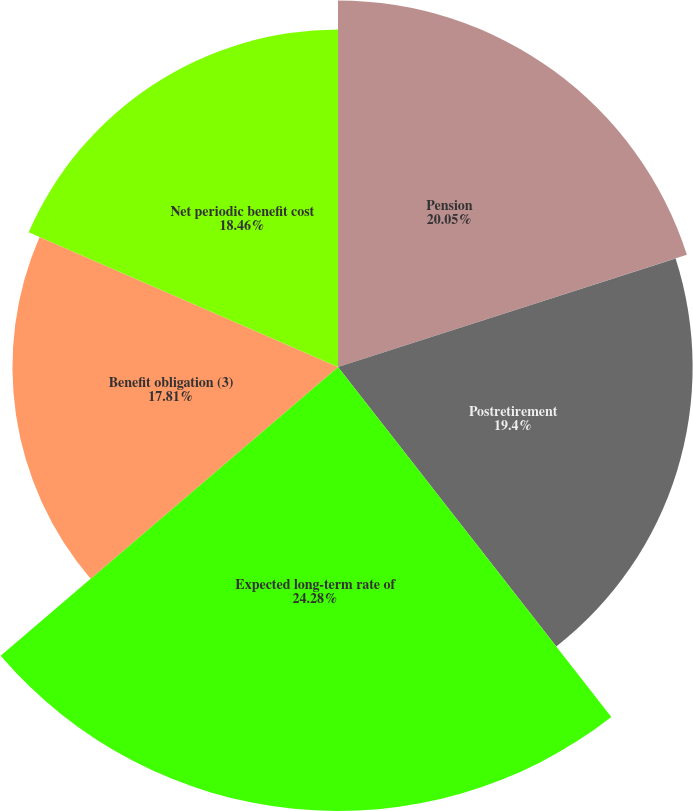Convert chart. <chart><loc_0><loc_0><loc_500><loc_500><pie_chart><fcel>Pension<fcel>Postretirement<fcel>Expected long-term rate of<fcel>Benefit obligation (3)<fcel>Net periodic benefit cost<nl><fcel>20.05%<fcel>19.4%<fcel>24.29%<fcel>17.81%<fcel>18.46%<nl></chart> 